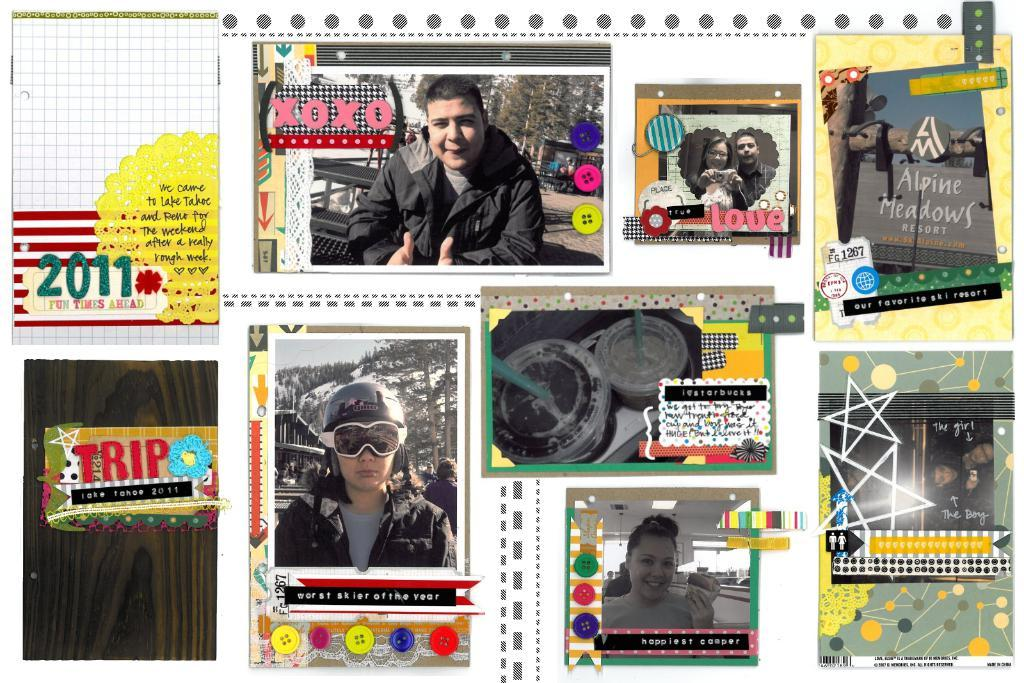What type of images can be seen in the picture? There are pictures of people and glasses in the image. What else is present in the image besides the pictures? There is text in the image. How are the pictures and text arranged in the image? There are frames around the pictures and text in the image. Can you see any jellyfish in the image? No, there are no jellyfish present in the image. What type of writing is being done in the image? There is no writing being done in the image; it only contains pictures, text, and frames. 